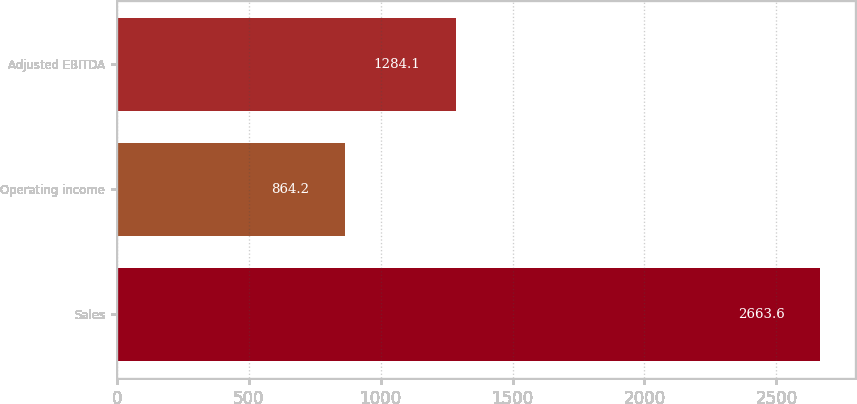<chart> <loc_0><loc_0><loc_500><loc_500><bar_chart><fcel>Sales<fcel>Operating income<fcel>Adjusted EBITDA<nl><fcel>2663.6<fcel>864.2<fcel>1284.1<nl></chart> 